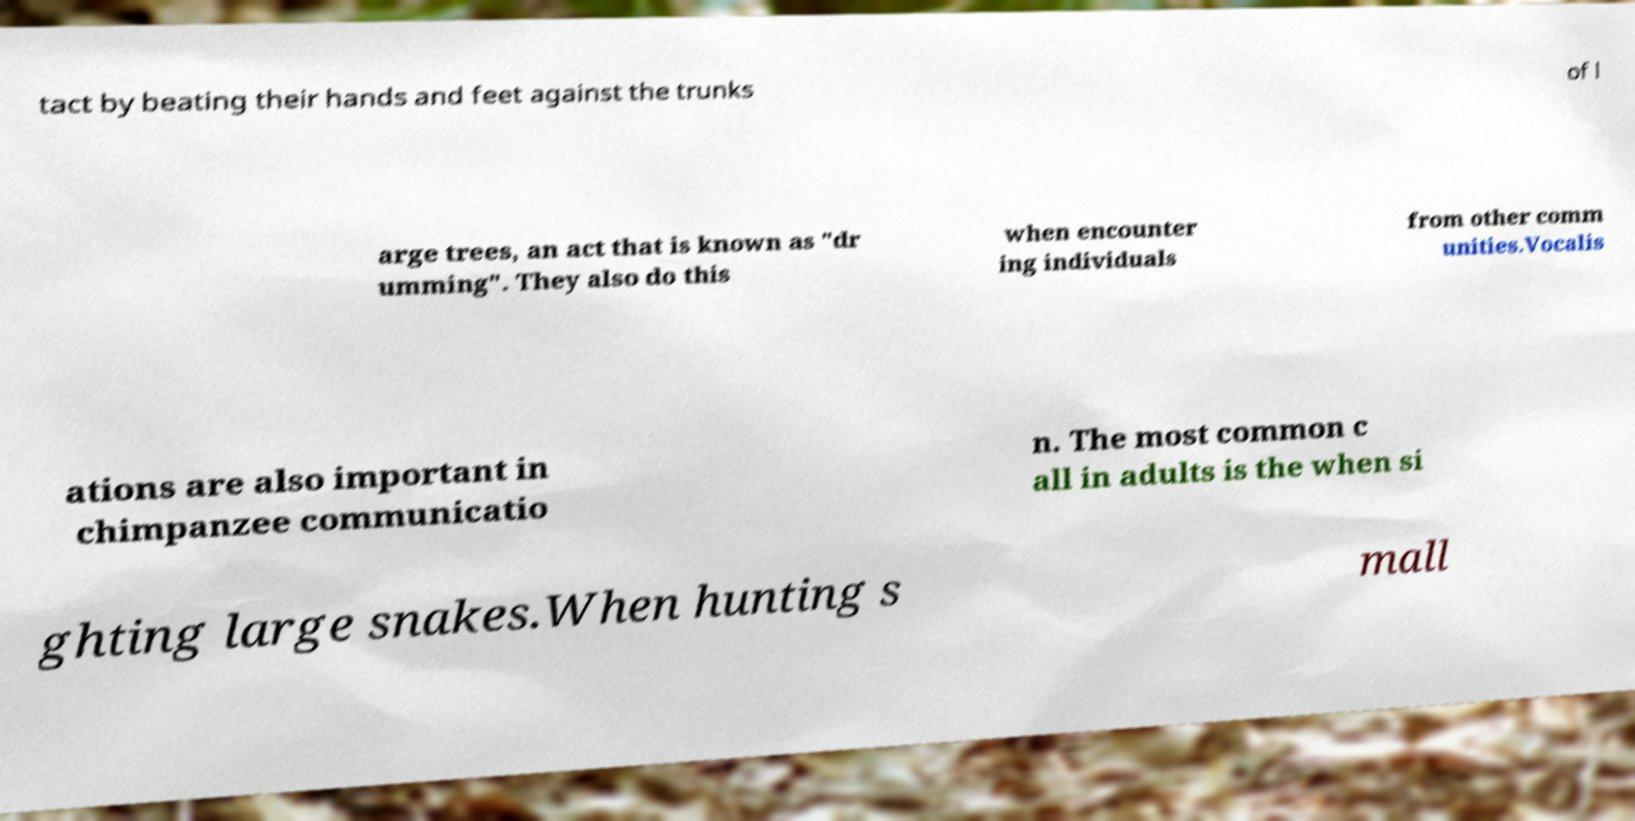There's text embedded in this image that I need extracted. Can you transcribe it verbatim? tact by beating their hands and feet against the trunks of l arge trees, an act that is known as "dr umming". They also do this when encounter ing individuals from other comm unities.Vocalis ations are also important in chimpanzee communicatio n. The most common c all in adults is the when si ghting large snakes.When hunting s mall 